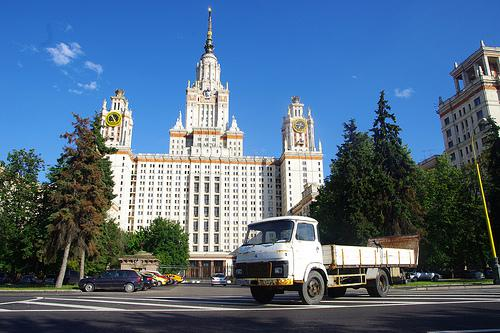Question: where are the trees?
Choices:
A. Behind the barn.
B. On the sides of the building.
C. In front of the river.
D. Along the sidewalk.
Answer with the letter. Answer: B Question: what is the white vehicle?
Choices:
A. A truck.
B. A car.
C. A motorcycle.
D. A bus.
Answer with the letter. Answer: A Question: why are the cars stationary?
Choices:
A. They are at a red light.
B. They are at a stop sign.
C. They are for sale.
D. They are parked.
Answer with the letter. Answer: D Question: how many white trucks are there?
Choices:
A. One.
B. Two.
C. Three.
D. Four.
Answer with the letter. Answer: A Question: what is in the background?
Choices:
A. A house.
B. A stadium.
C. A soccer field.
D. A building.
Answer with the letter. Answer: D 